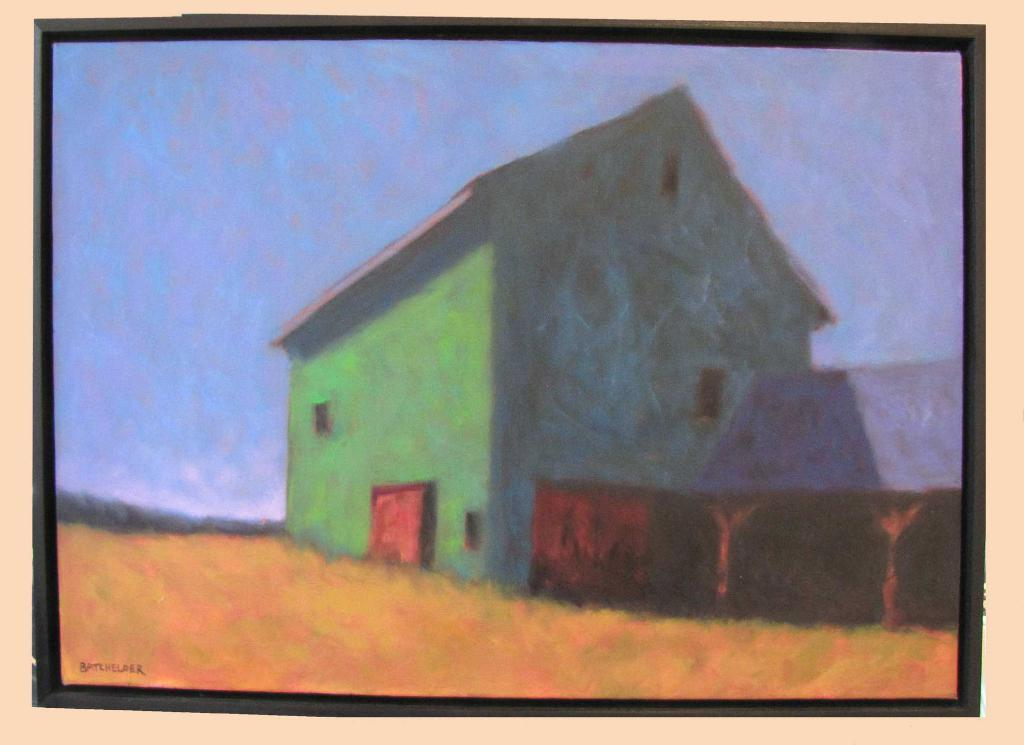What is the main subject of the image? There is a painting in the image. What does the painting appear to depict? The painting appears to depict a house. Is there any text present in the image? Yes, there is text at the bottom left corner of the image. Can you tell me how many scarecrows are standing in front of the house in the painting? There are no scarecrows present in the painting; it depicts a house. What type of window can be seen in the painting? There is no window visible in the painting, as it depicts a house as a whole. 